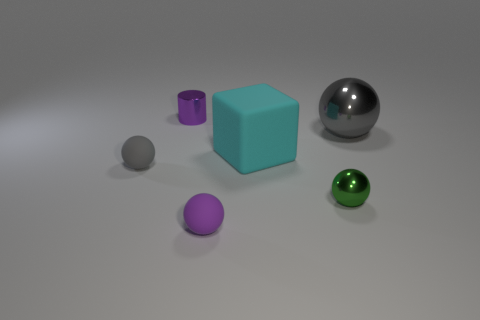Is there anything else that is the same material as the large gray object?
Offer a very short reply. Yes. There is a big object that is made of the same material as the tiny purple sphere; what shape is it?
Make the answer very short. Cube. Is the number of small purple spheres that are to the left of the small gray rubber ball less than the number of tiny cylinders that are right of the large rubber object?
Give a very brief answer. No. How many tiny things are gray matte things or green metal things?
Keep it short and to the point. 2. There is a small purple thing behind the large matte block; does it have the same shape as the large object that is to the left of the tiny metal ball?
Your answer should be compact. No. There is a purple thing behind the gray sphere to the right of the metal thing in front of the large block; what size is it?
Your answer should be very brief. Small. There is a gray sphere that is on the left side of the big cyan matte cube; what is its size?
Ensure brevity in your answer.  Small. There is a gray thing that is on the right side of the rubber cube; what is it made of?
Provide a short and direct response. Metal. How many red things are either small rubber balls or metallic things?
Your answer should be very brief. 0. Does the tiny green ball have the same material as the tiny purple object that is behind the tiny gray sphere?
Make the answer very short. Yes. 